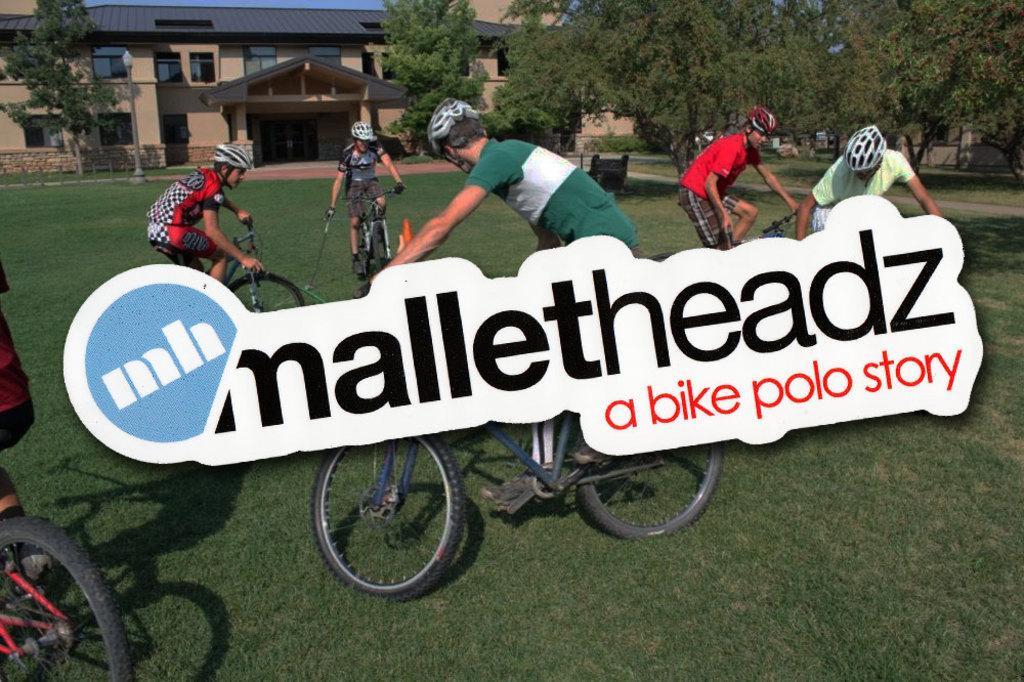How would you summarize this image in a sentence or two? In image I can see people are cycling their cycles, I can also see all of them are wearing helmets. In the background I can see number of trees and a building. 